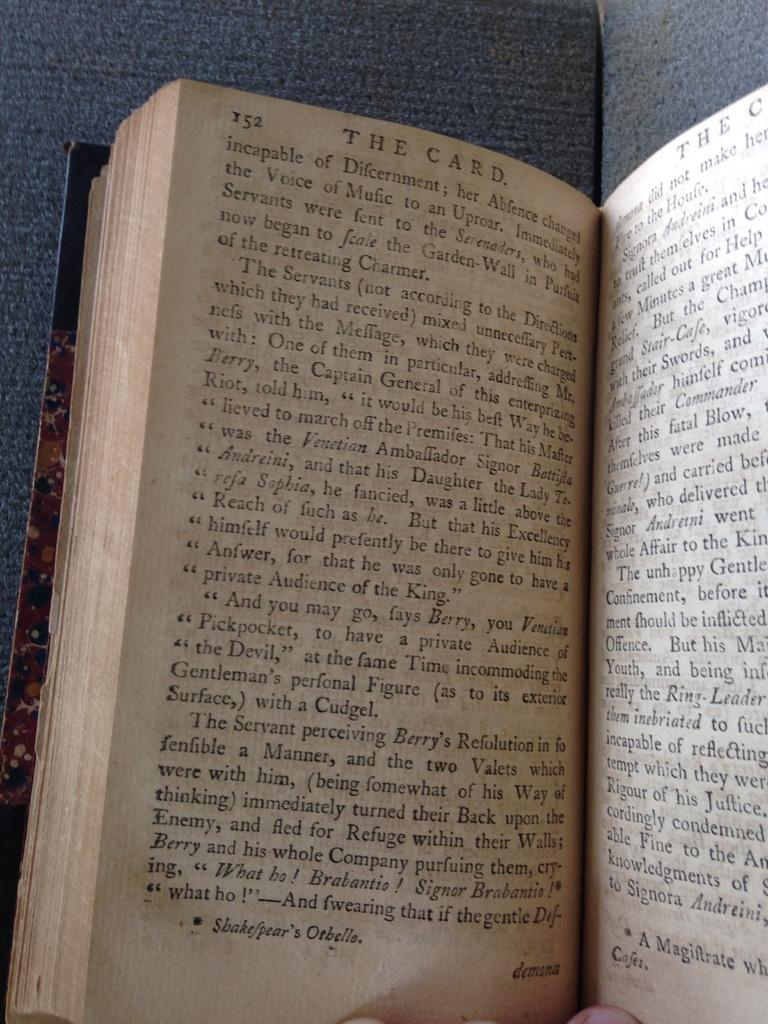<image>
Offer a succinct explanation of the picture presented. A book is open to page 152/153 and the title at the top of the page reads THE CARD. 